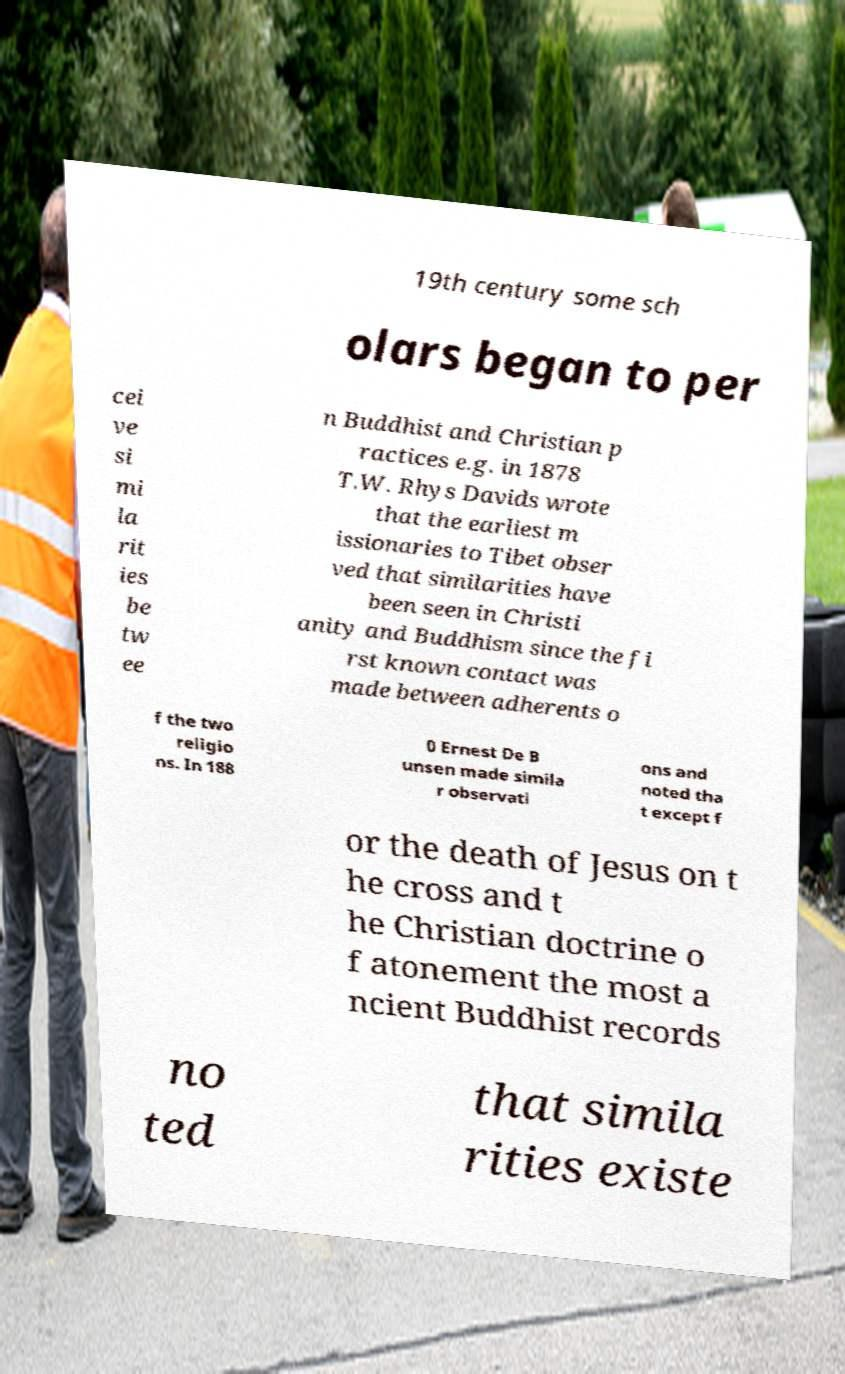I need the written content from this picture converted into text. Can you do that? 19th century some sch olars began to per cei ve si mi la rit ies be tw ee n Buddhist and Christian p ractices e.g. in 1878 T.W. Rhys Davids wrote that the earliest m issionaries to Tibet obser ved that similarities have been seen in Christi anity and Buddhism since the fi rst known contact was made between adherents o f the two religio ns. In 188 0 Ernest De B unsen made simila r observati ons and noted tha t except f or the death of Jesus on t he cross and t he Christian doctrine o f atonement the most a ncient Buddhist records no ted that simila rities existe 